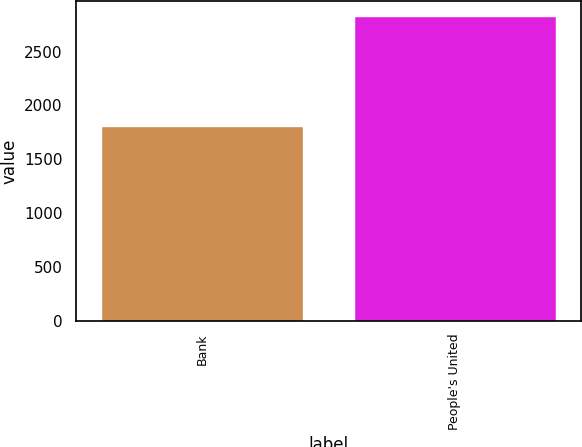Convert chart. <chart><loc_0><loc_0><loc_500><loc_500><bar_chart><fcel>Bank<fcel>People's United<nl><fcel>1805.4<fcel>2827.9<nl></chart> 